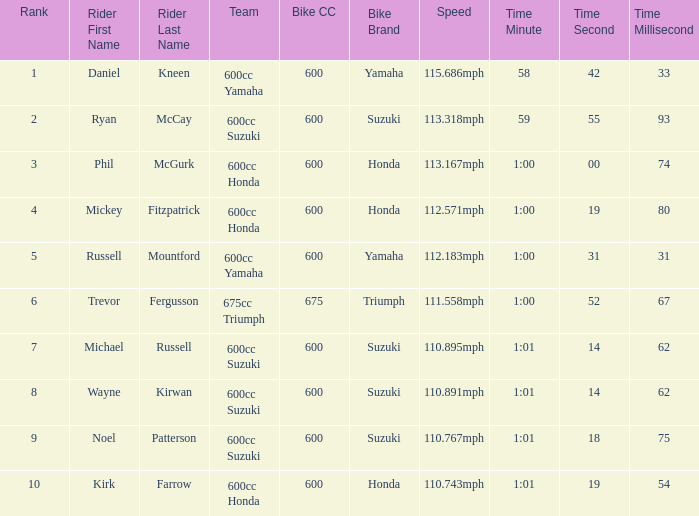How many ranks have 1:01.14.62 as the time, with michael russell as the rider? 1.0. 